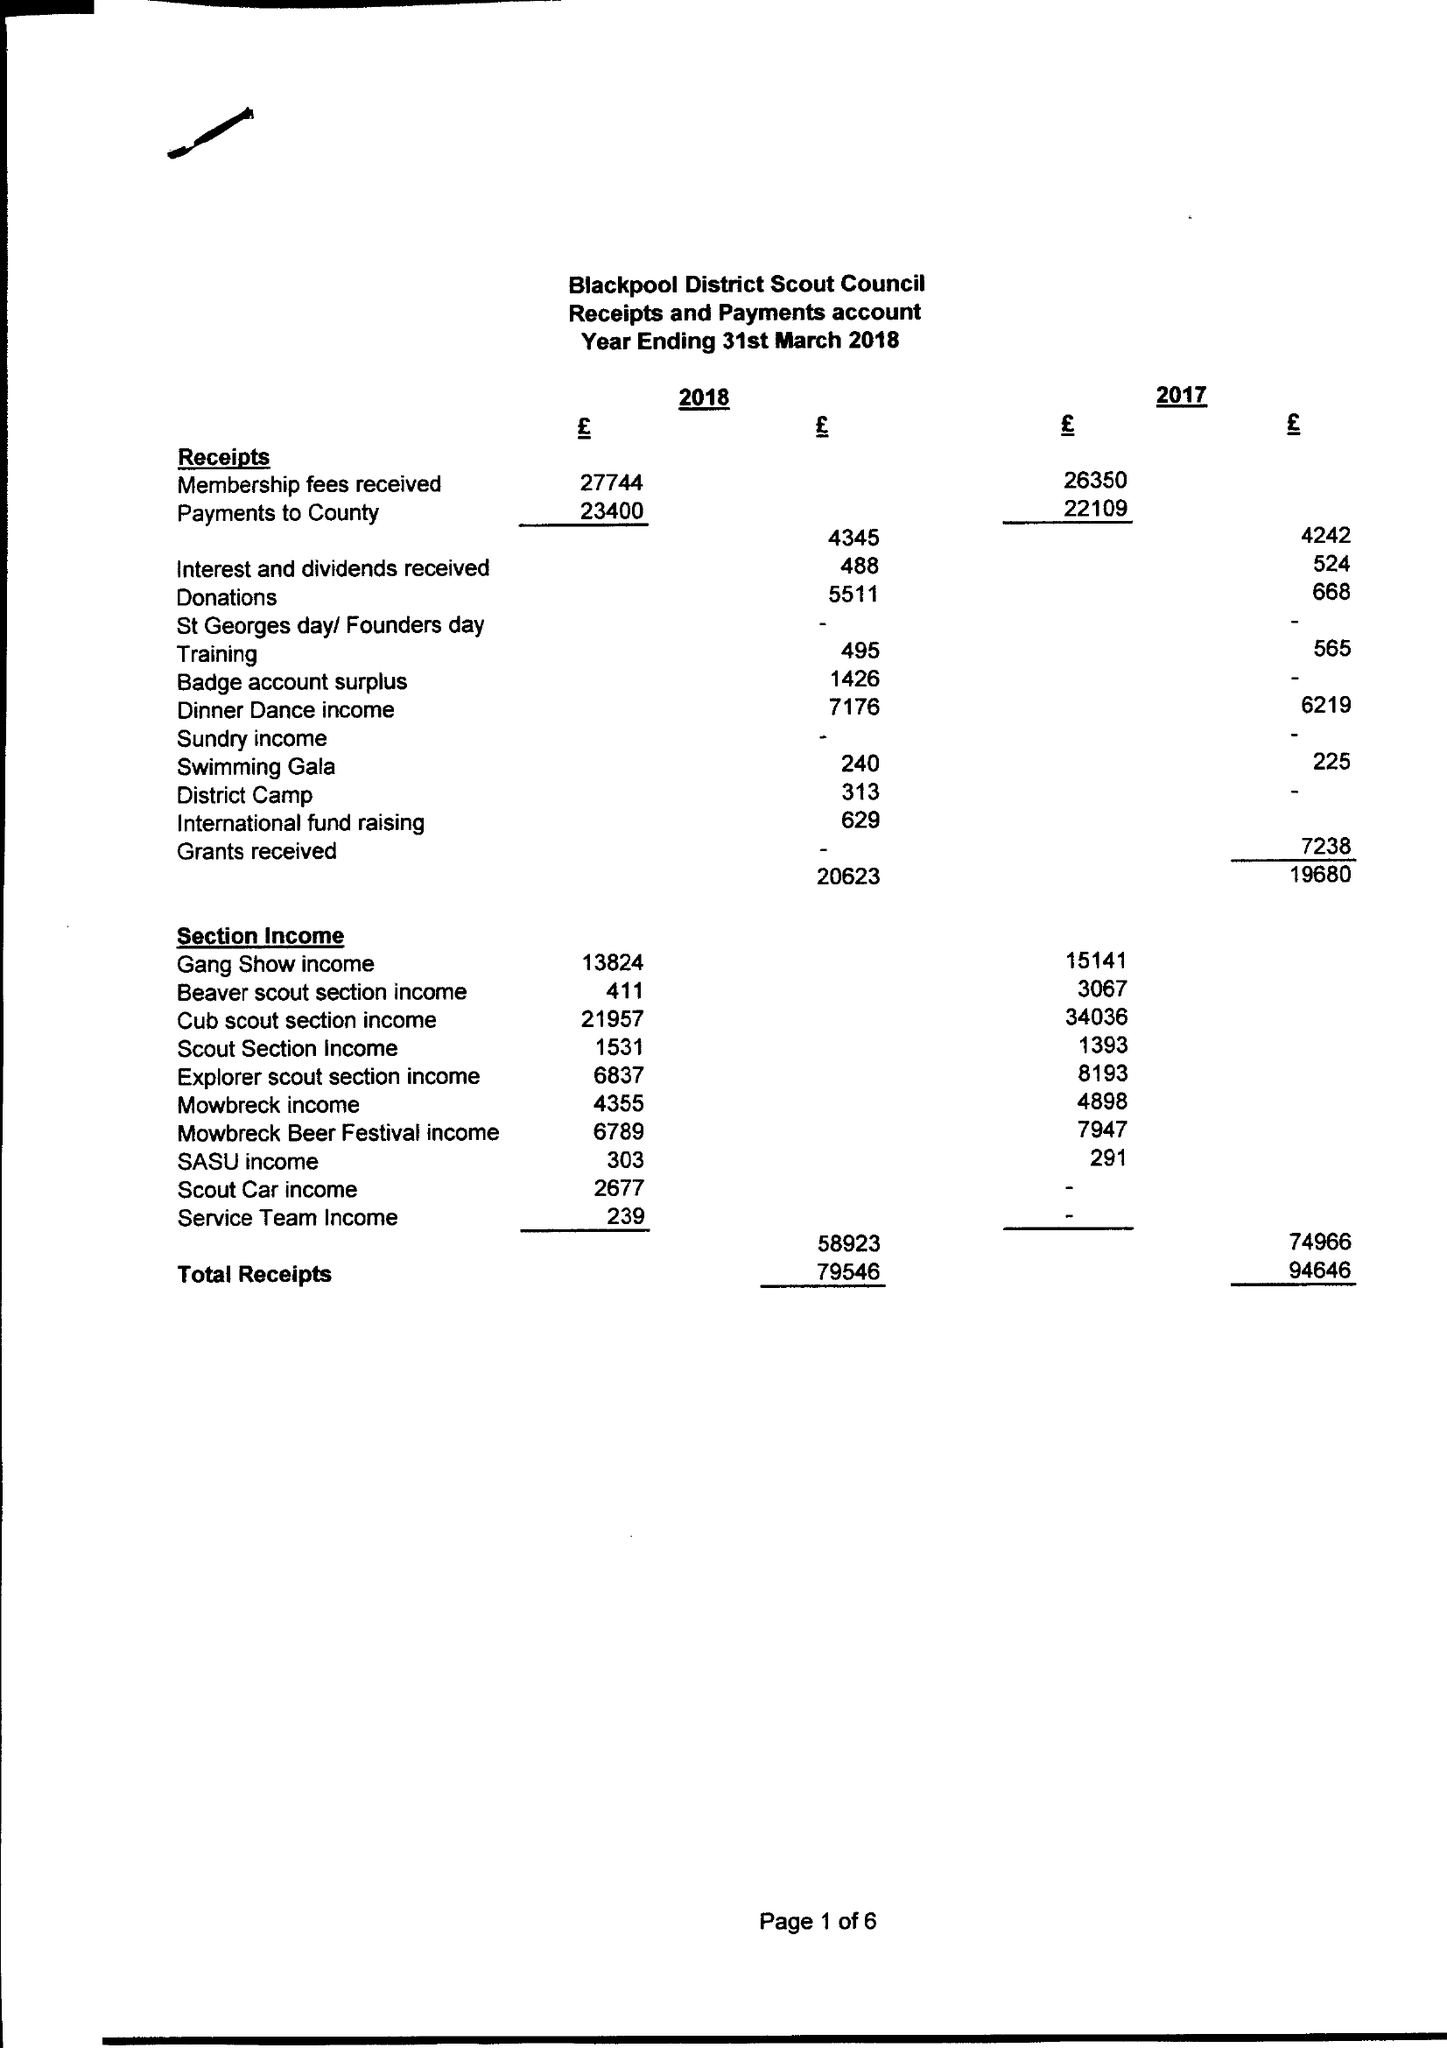What is the value for the address__post_town?
Answer the question using a single word or phrase. BLACKPOOL 